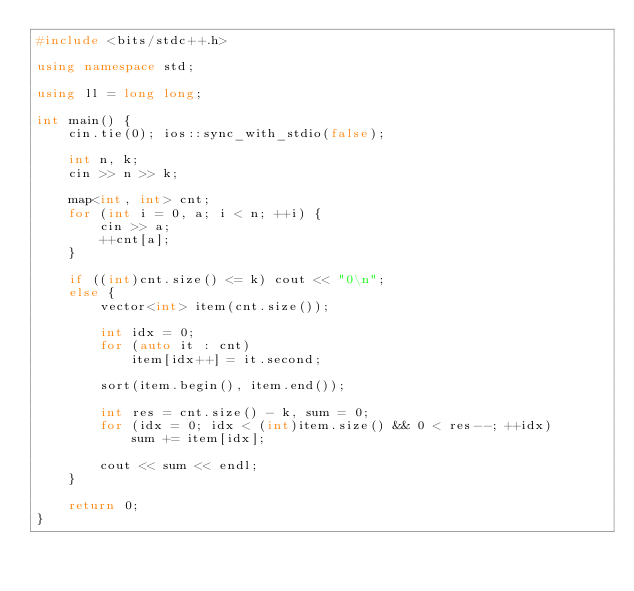<code> <loc_0><loc_0><loc_500><loc_500><_C++_>#include <bits/stdc++.h>

using namespace std;

using ll = long long;

int main() {
    cin.tie(0); ios::sync_with_stdio(false);

    int n, k;
    cin >> n >> k;

    map<int, int> cnt;
    for (int i = 0, a; i < n; ++i) {
        cin >> a;
        ++cnt[a];
    }

    if ((int)cnt.size() <= k) cout << "0\n";
    else {
        vector<int> item(cnt.size());

        int idx = 0;
        for (auto it : cnt)
            item[idx++] = it.second;

        sort(item.begin(), item.end());

        int res = cnt.size() - k, sum = 0;
        for (idx = 0; idx < (int)item.size() && 0 < res--; ++idx)
            sum += item[idx];

        cout << sum << endl;
    }

    return 0;
}
</code> 